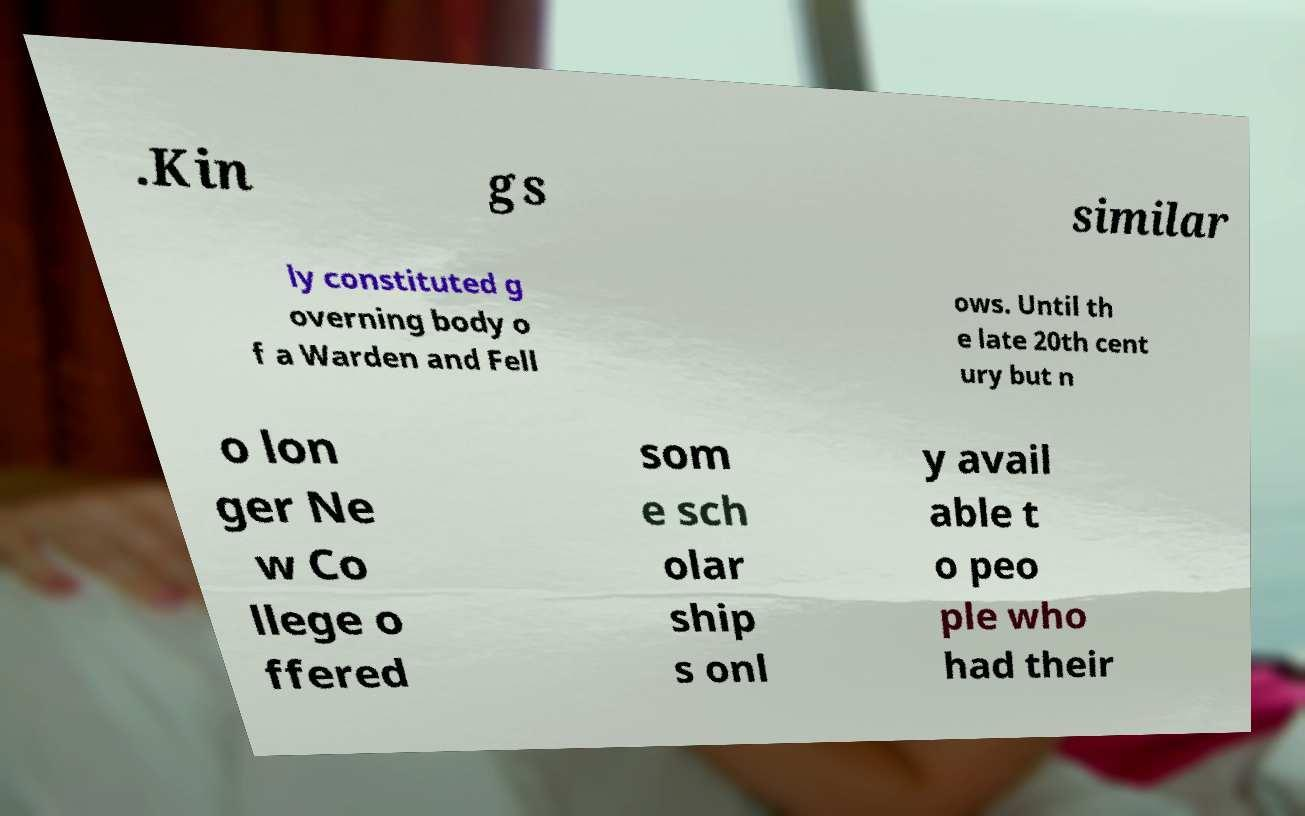Could you extract and type out the text from this image? .Kin gs similar ly constituted g overning body o f a Warden and Fell ows. Until th e late 20th cent ury but n o lon ger Ne w Co llege o ffered som e sch olar ship s onl y avail able t o peo ple who had their 